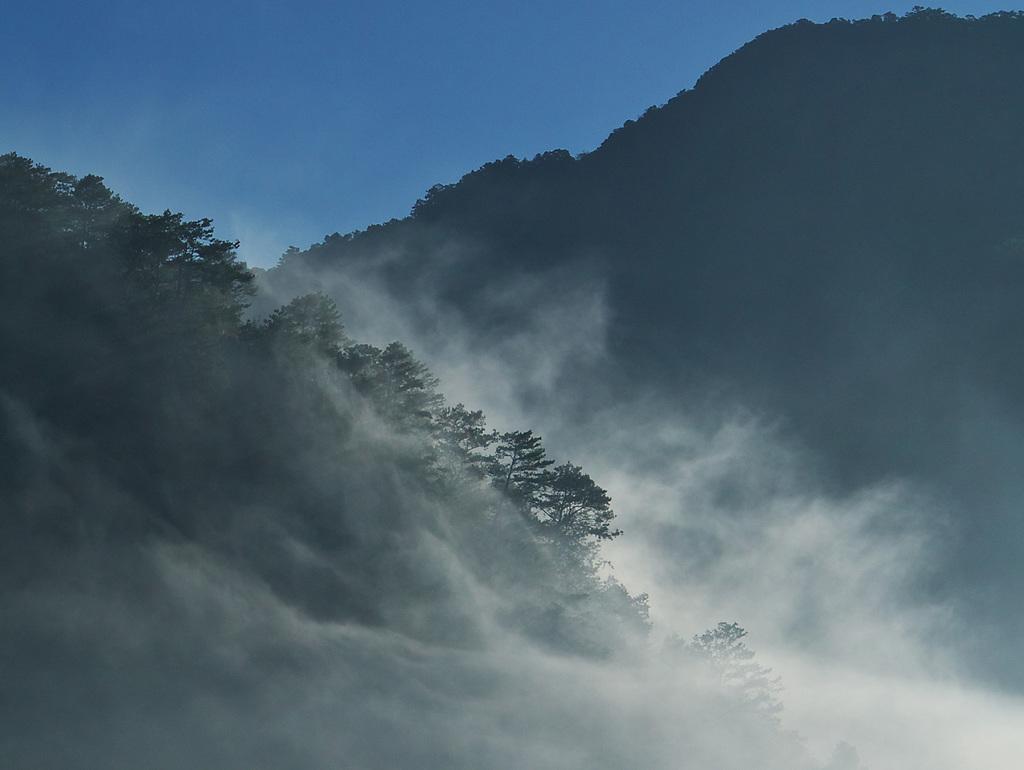Could you give a brief overview of what you see in this image? In this picture we can see fog in the front, on the left side there are some trees, we can see the sky at the top of the picture. 